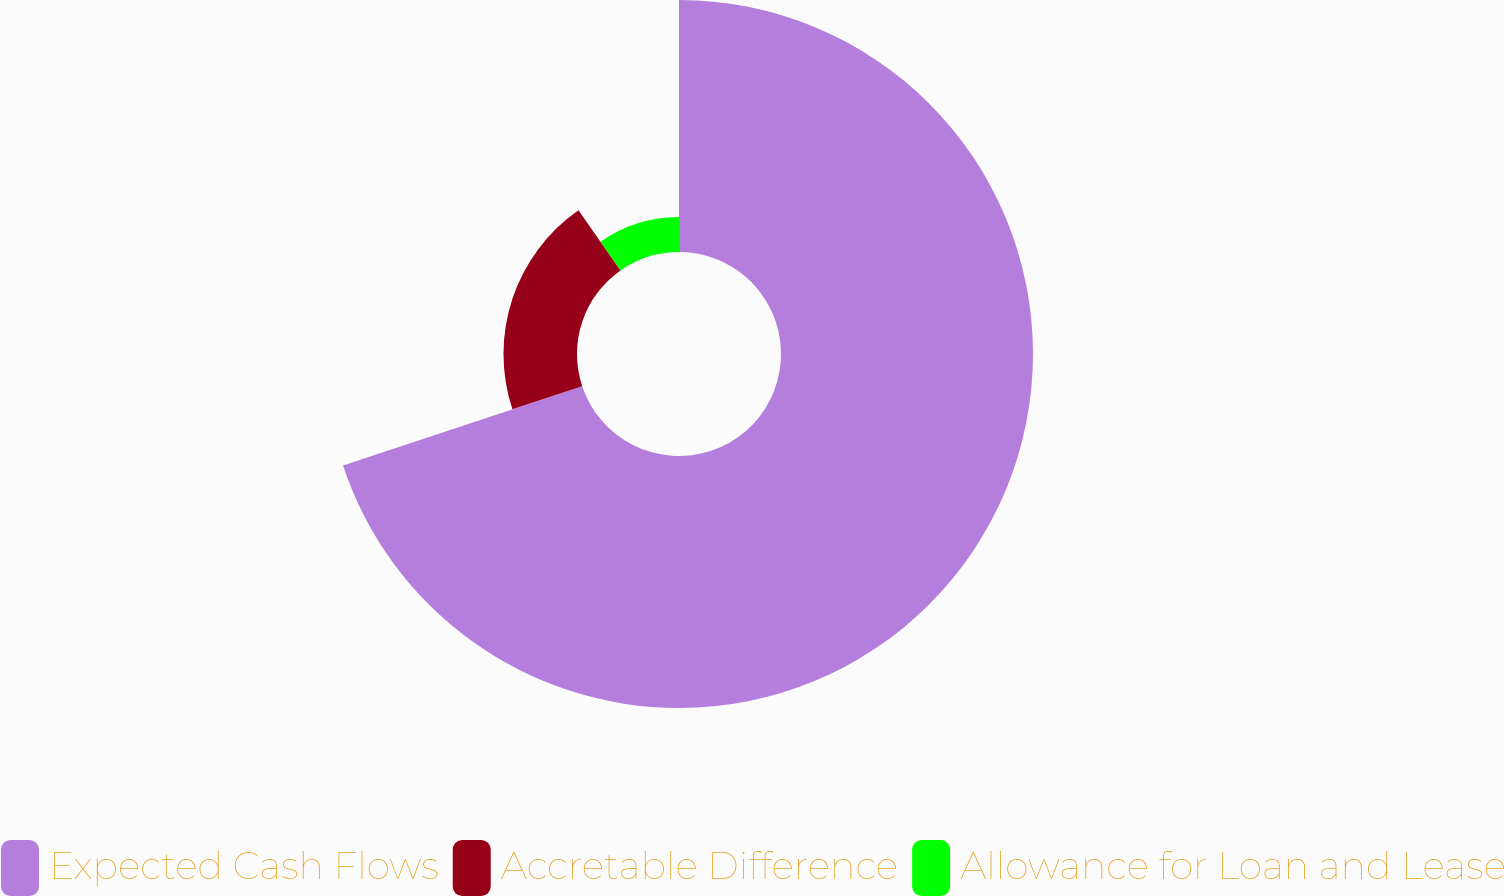Convert chart to OTSL. <chart><loc_0><loc_0><loc_500><loc_500><pie_chart><fcel>Expected Cash Flows<fcel>Accretable Difference<fcel>Allowance for Loan and Lease<nl><fcel>69.9%<fcel>20.39%<fcel>9.71%<nl></chart> 